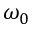<formula> <loc_0><loc_0><loc_500><loc_500>\omega _ { 0 }</formula> 